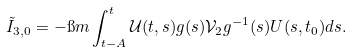<formula> <loc_0><loc_0><loc_500><loc_500>& \tilde { I } _ { 3 , 0 } = - \i m \int _ { t - A } ^ { t } \mathcal { U } ( t , s ) g ( s ) \mathcal { V } _ { 2 } g ^ { - 1 } ( s ) U ( s , t _ { 0 } ) d s .</formula> 